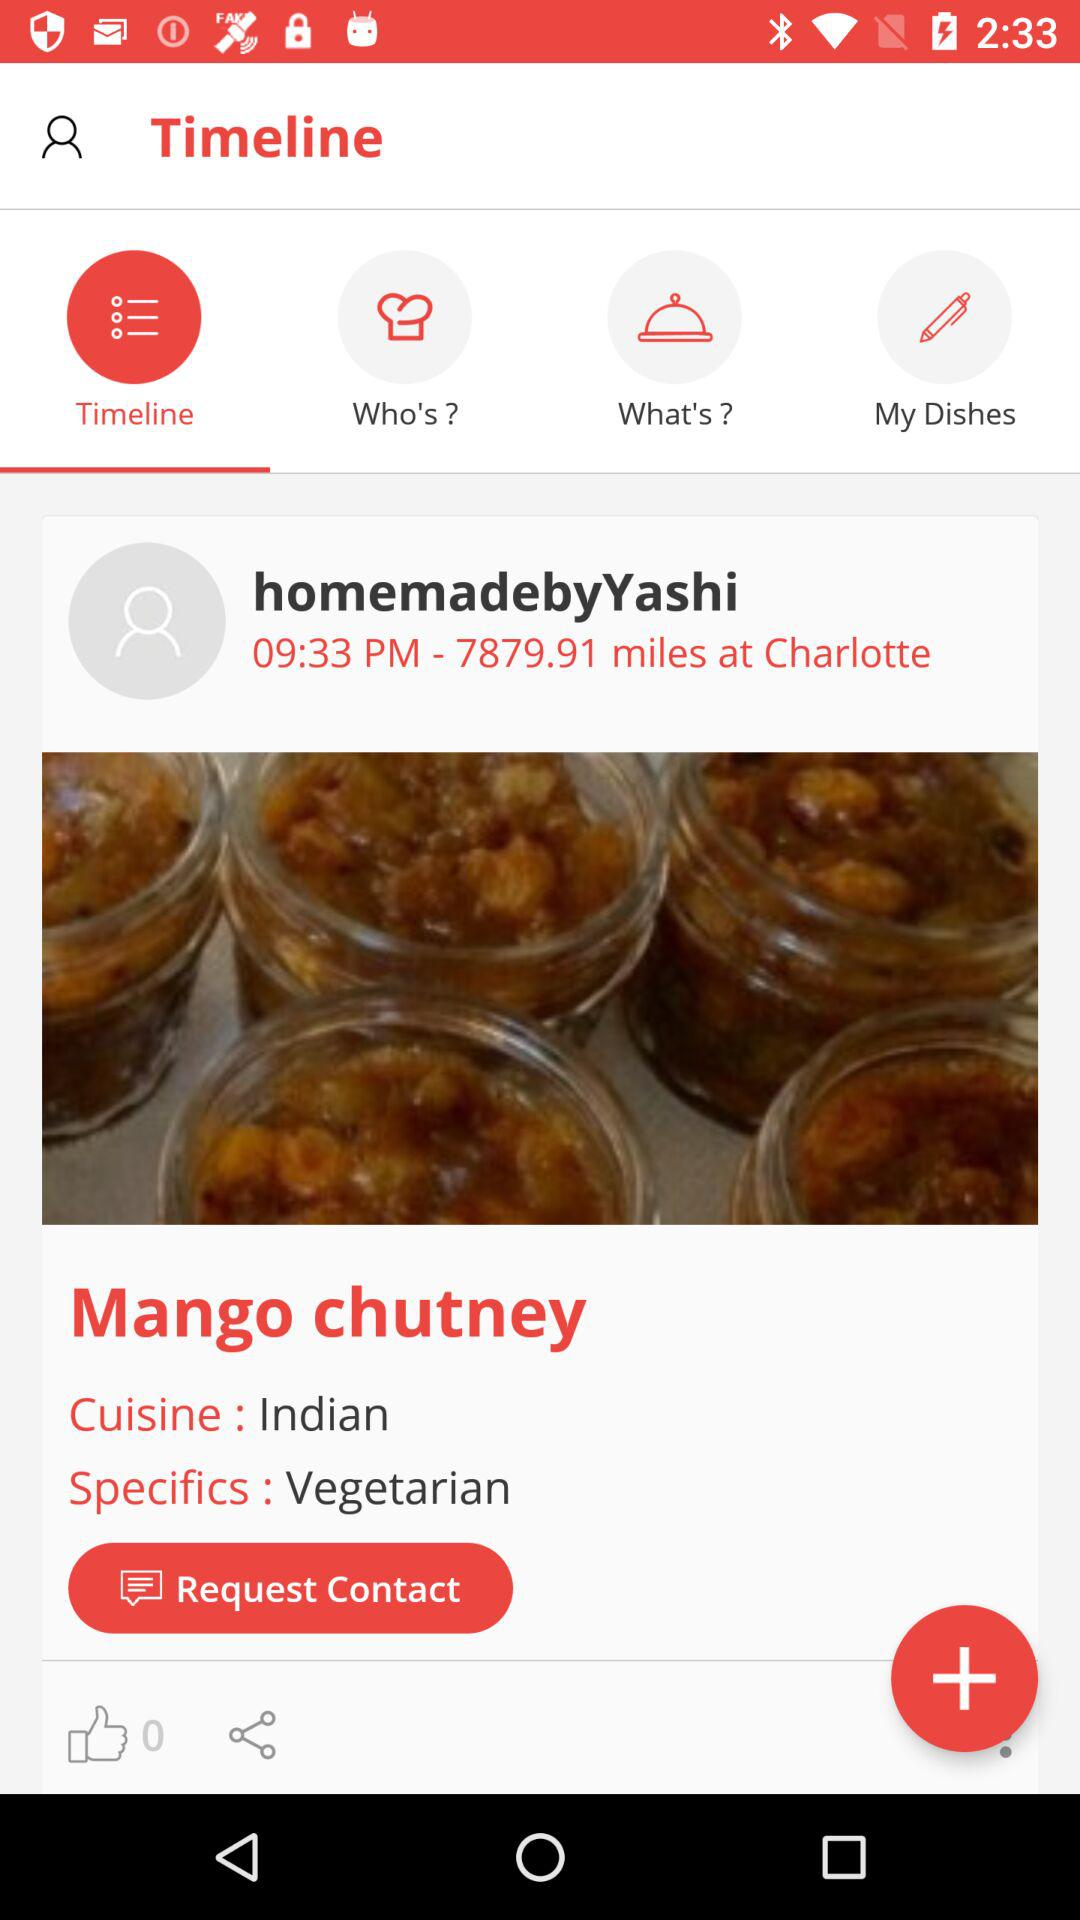Which tab is selected? The selected tab is "Timeline". 